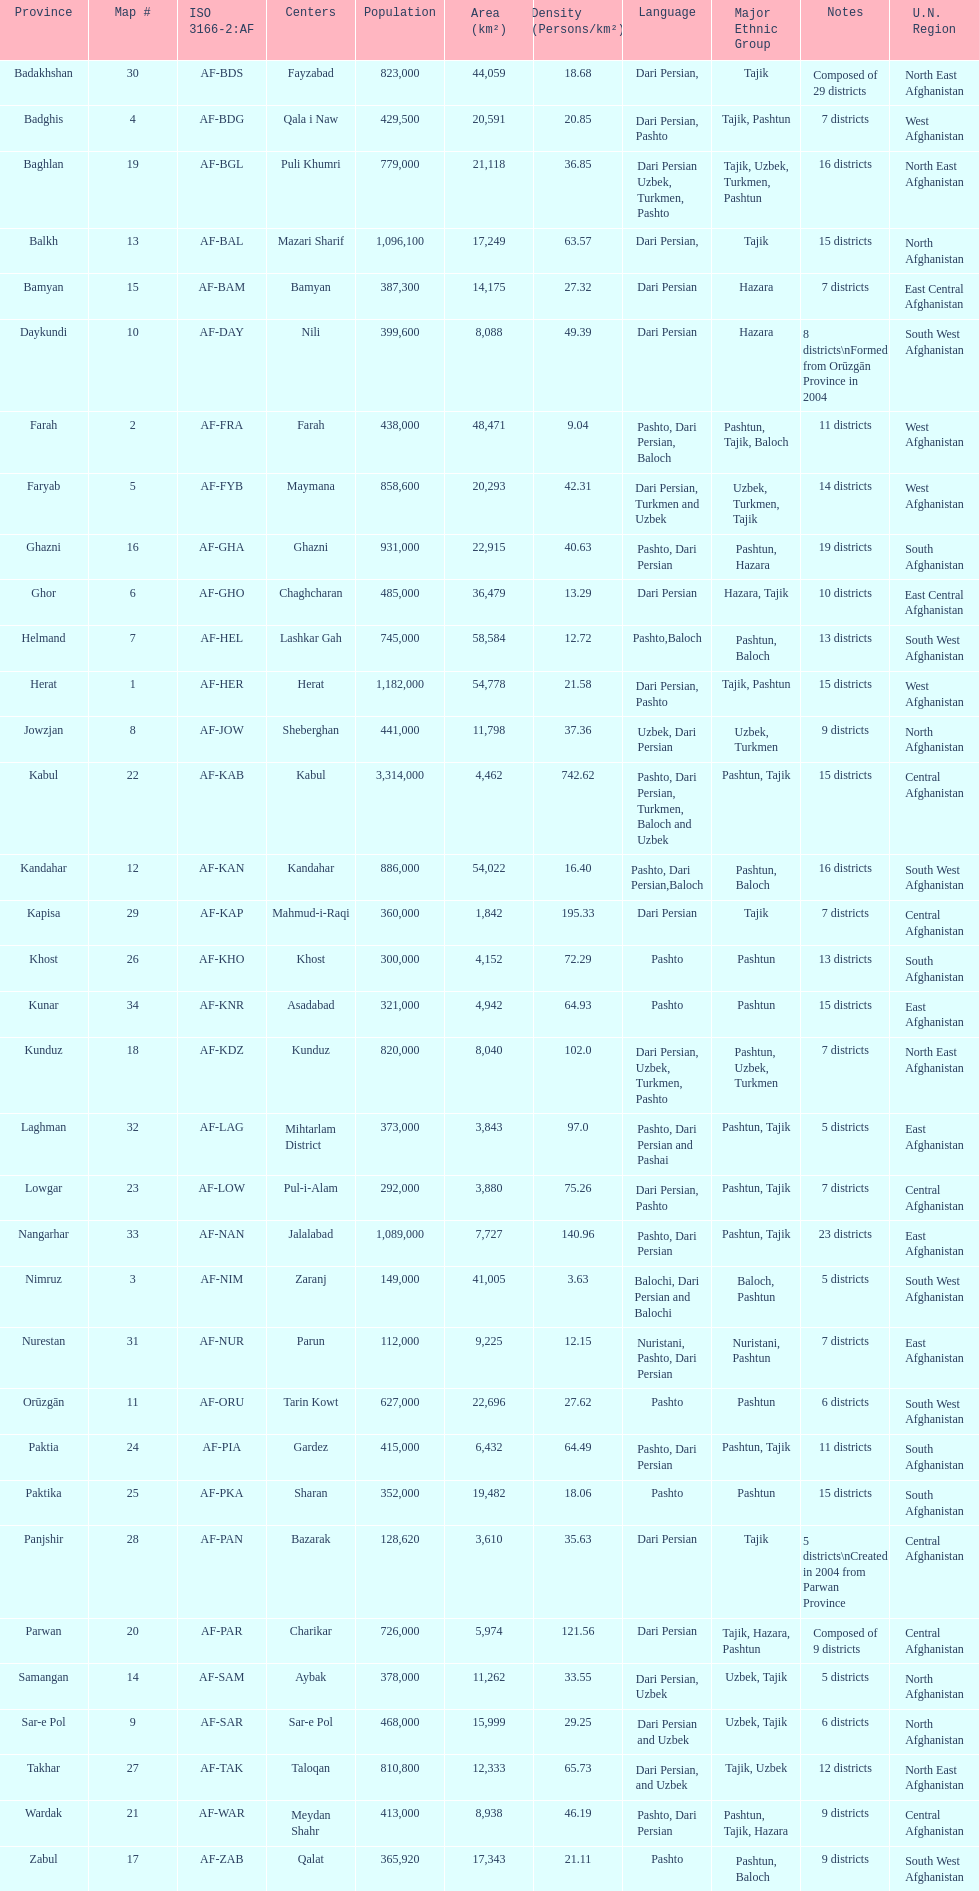What province is listed previous to ghor? Ghazni. 